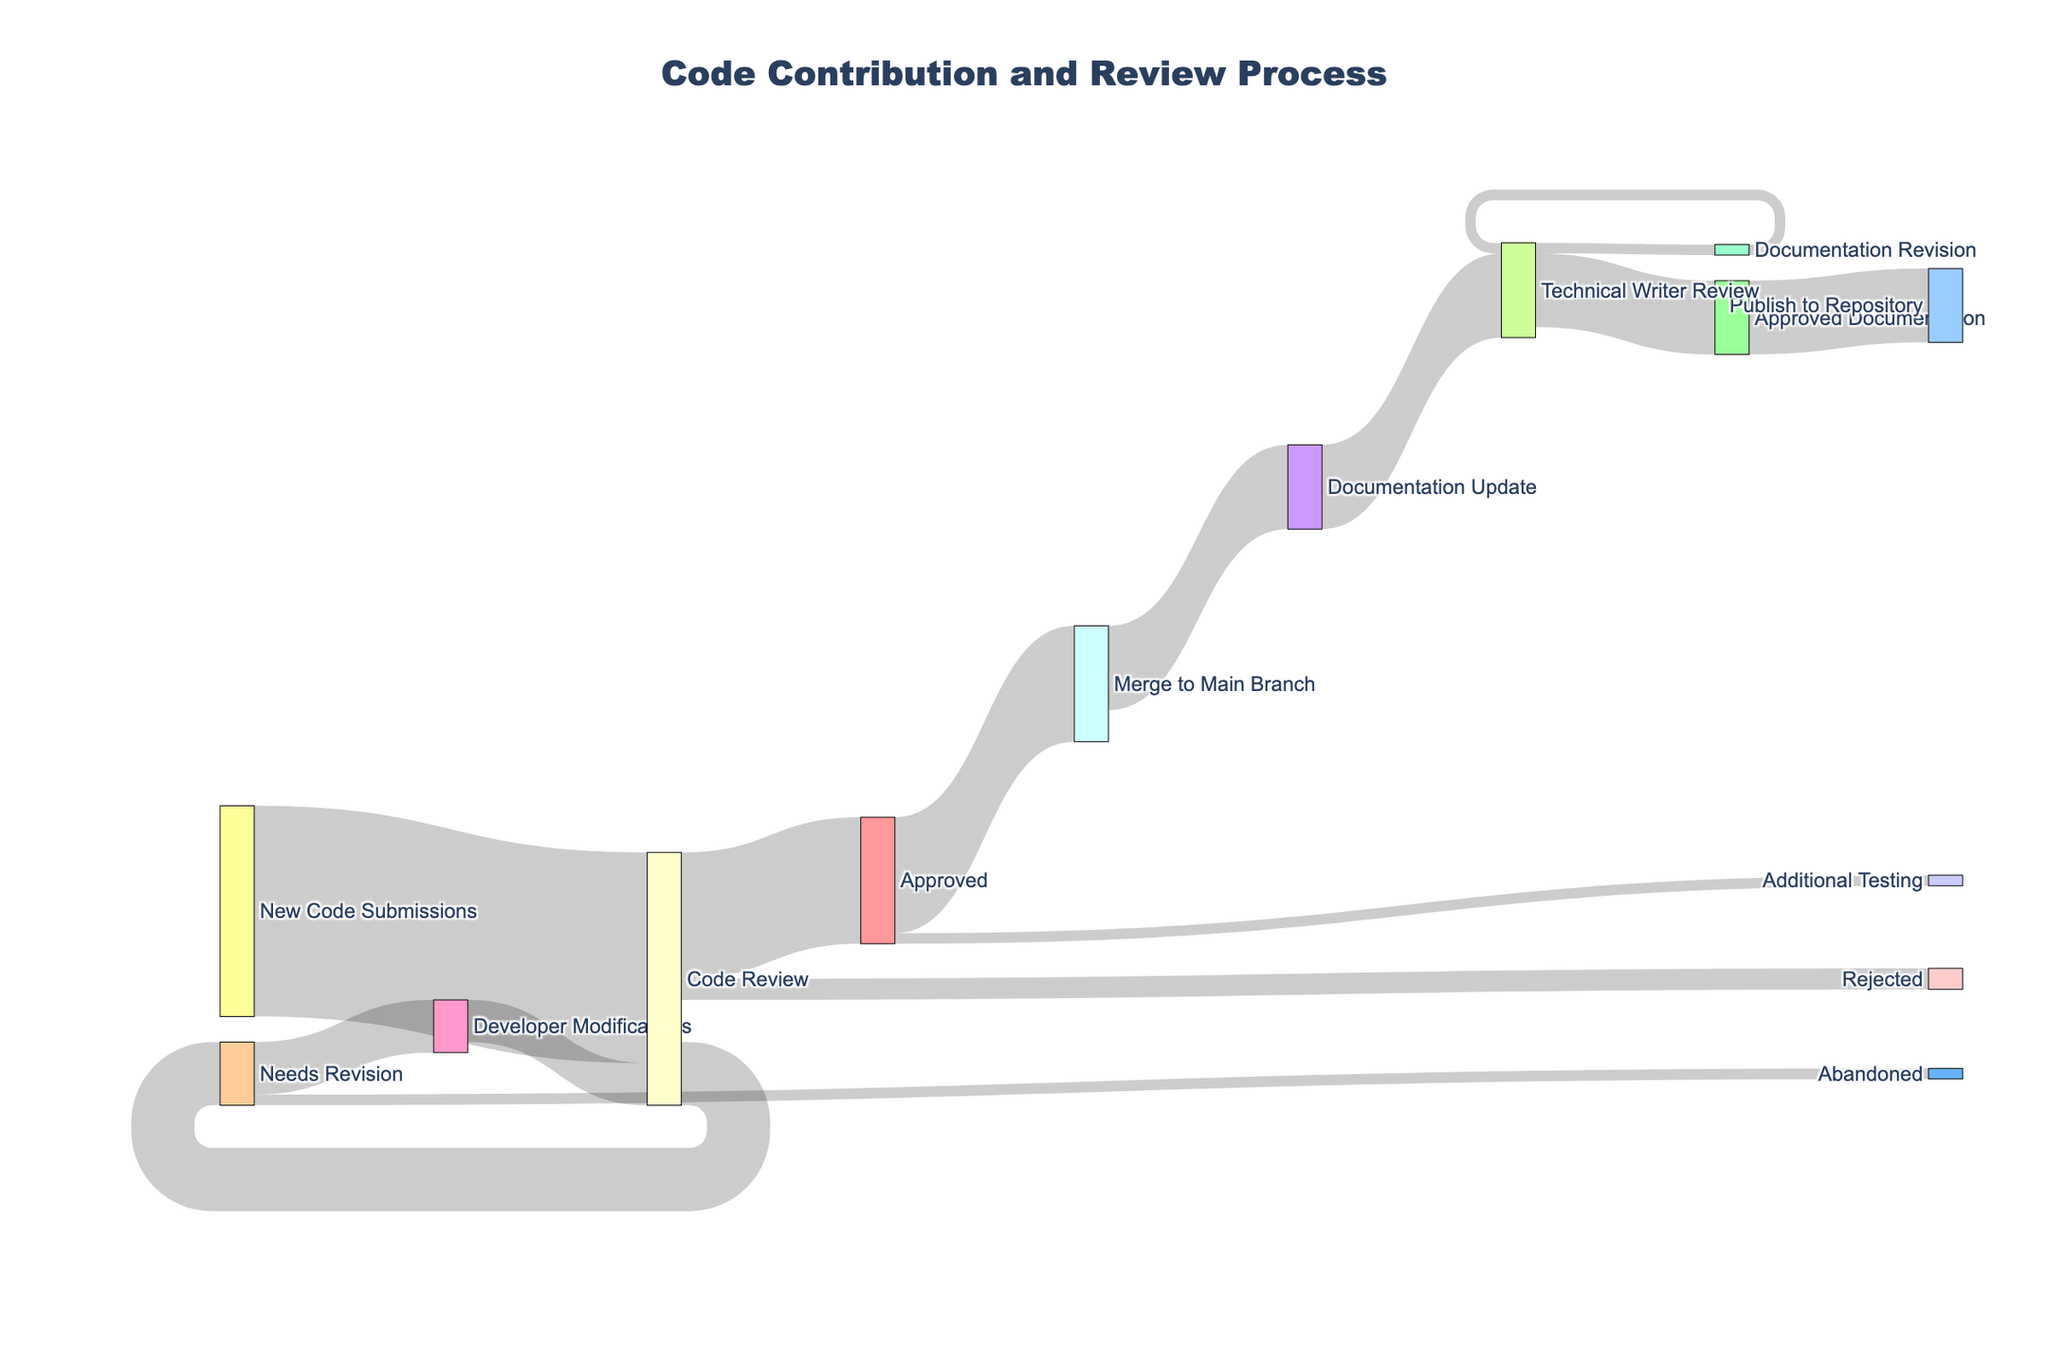What is the title of the diagram? The title of the diagram is usually found at the top, indicating the main subject or content of the chart. In this case, the title is "Code Contribution and Review Process".
Answer: Code Contribution and Review Process How many processes are involved after code is approved? Look at all the nodes connected to "Approved". They are "Merge to Main Branch" and "Additional Testing". Count these nodes to get the total number of processes.
Answer: 2 What happens to the majority of approved codes? Track the flow from the "Approved" node to its targets. "Merge to Main Branch" has a value of 55, while "Additional Testing" has a value of 5. Therefore, most of the approved codes are merged to the main branch.
Answer: Merge to Main Branch Which stage has the highest number of nodes flowing into it? Identify the stage (node) that has the most connections leading into it. "Technical Writer Review" has flows from "Documentation Update" (40) and "Documentation Revision" (5).
Answer: Technical Writer Review What percentage of new code submissions needs revision after the initial code review? Calculate the proportion of "Needs Revision" out of the total "Code Review". The "Needs Revision" value is 30 and the "Code Review" value is 100. The percentage is (30/100) * 100.
Answer: 30% How many stages are there from code submission to published documentation? Count all the nodes from "New Code Submissions" to "Publish to Repository". They are: New Code Submissions → Code Review → Approved → Merge to Main Branch → Documentation Update → Technical Writer Review → Approved Documentation → Publish to Repository
Answer: 8 What happens to the documentation after it's been updated? Follow the flow from the node "Documentation Update". It leads solely to "Technical Writer Review" with a value of 40.
Answer: Sent to Technical Writer Review What is the next step for code that needs revision after code review and is subsequently modified by developers? Track the flow from "Needs Revision" to "Developer Modifications", then see where "Developer Modifications" leads. The flow returns to "Code Review".
Answer: Code Review Compare the number of approved documentation pieces with those needing revision from Technical Writer Review? Look at the values flowing out from "Technical Writer Review". "Approved Documentation" has 35, while "Documentation Revision" has 5. Clearly, more documentation pieces are approved than those needing revision.
Answer: Approved Documentation has more How many code submissions are ultimately rejected after the review process? Track the value directly from "Code Review" to "Rejected", which is given as 10.
Answer: 10 